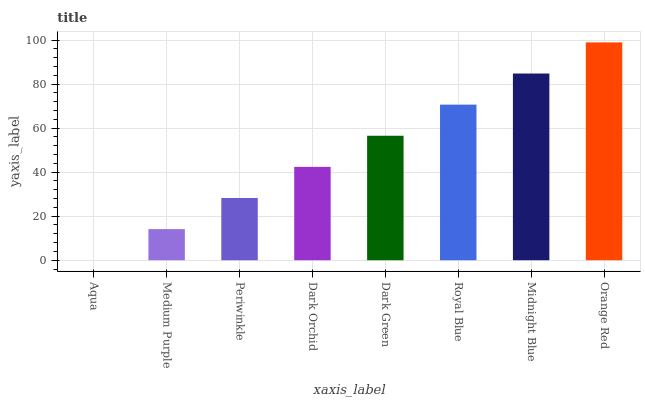Is Aqua the minimum?
Answer yes or no. Yes. Is Orange Red the maximum?
Answer yes or no. Yes. Is Medium Purple the minimum?
Answer yes or no. No. Is Medium Purple the maximum?
Answer yes or no. No. Is Medium Purple greater than Aqua?
Answer yes or no. Yes. Is Aqua less than Medium Purple?
Answer yes or no. Yes. Is Aqua greater than Medium Purple?
Answer yes or no. No. Is Medium Purple less than Aqua?
Answer yes or no. No. Is Dark Green the high median?
Answer yes or no. Yes. Is Dark Orchid the low median?
Answer yes or no. Yes. Is Orange Red the high median?
Answer yes or no. No. Is Medium Purple the low median?
Answer yes or no. No. 